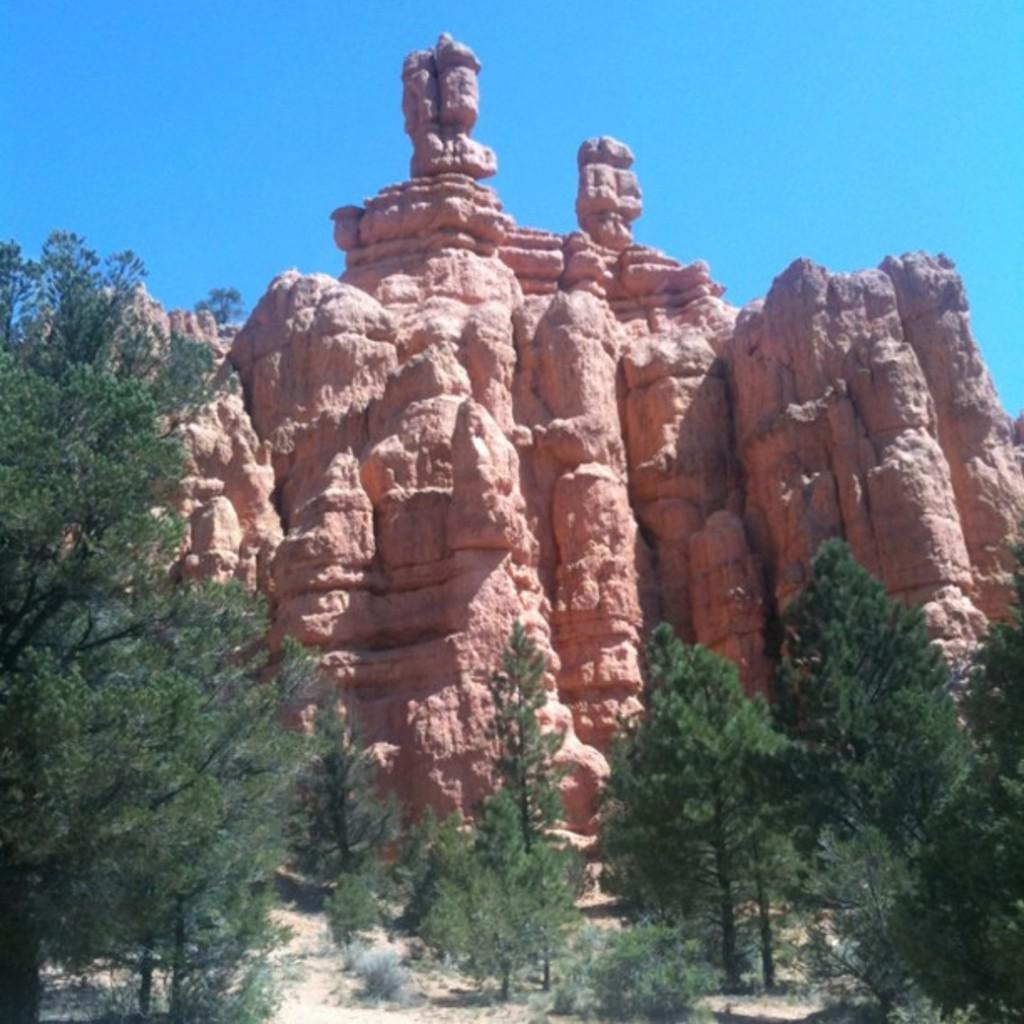What type of landform is present in the image? There is a hill in the image. What type of vegetation can be seen in the image? There are trees in the image. What is visible at the top of the image? The sky is visible at the top of the image. What is visible at the bottom of the image? The ground is visible at the bottom of the image. How many chairs can be seen in the image? There are no chairs present in the image. 